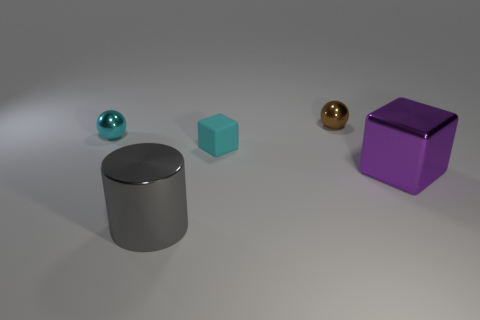Is the size of the cyan object that is behind the rubber block the same as the big shiny cube?
Keep it short and to the point. No. Are there any metallic objects that have the same color as the small cube?
Your answer should be very brief. Yes. There is a cyan sphere that is the same material as the big gray cylinder; what is its size?
Keep it short and to the point. Small. Is the number of big metal cylinders left of the tiny brown ball greater than the number of shiny cylinders that are behind the big gray shiny thing?
Give a very brief answer. Yes. How many other things are there of the same material as the small brown object?
Offer a very short reply. 3. Do the thing in front of the large metal block and the tiny brown object have the same material?
Give a very brief answer. Yes. What is the shape of the small brown shiny object?
Make the answer very short. Sphere. Is the number of tiny cyan objects that are behind the small cube greater than the number of brown blocks?
Ensure brevity in your answer.  Yes. Are there any other things that have the same shape as the gray shiny thing?
Offer a very short reply. No. There is another small object that is the same shape as the purple shiny thing; what is its color?
Provide a succinct answer. Cyan. 